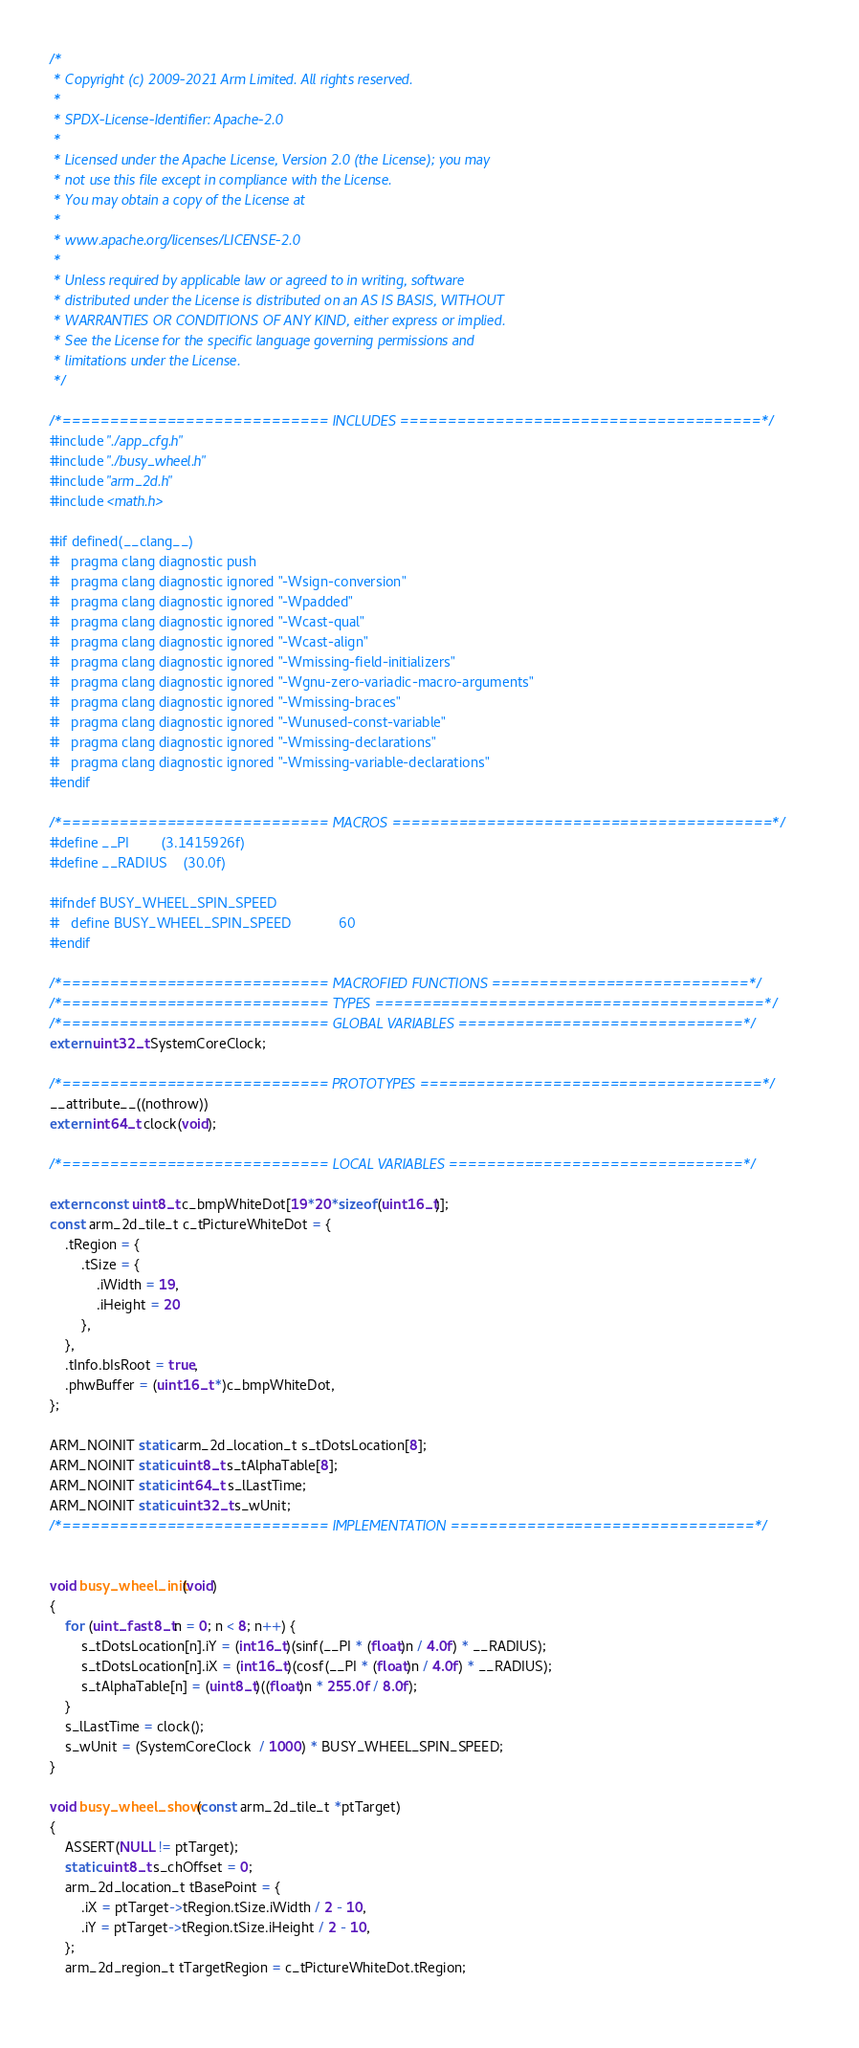<code> <loc_0><loc_0><loc_500><loc_500><_C_>/*
 * Copyright (c) 2009-2021 Arm Limited. All rights reserved.
 *
 * SPDX-License-Identifier: Apache-2.0
 *
 * Licensed under the Apache License, Version 2.0 (the License); you may
 * not use this file except in compliance with the License.
 * You may obtain a copy of the License at
 *
 * www.apache.org/licenses/LICENSE-2.0
 *
 * Unless required by applicable law or agreed to in writing, software
 * distributed under the License is distributed on an AS IS BASIS, WITHOUT
 * WARRANTIES OR CONDITIONS OF ANY KIND, either express or implied.
 * See the License for the specific language governing permissions and
 * limitations under the License.
 */

/*============================ INCLUDES ======================================*/
#include "./app_cfg.h"
#include "./busy_wheel.h"
#include "arm_2d.h"
#include <math.h>

#if defined(__clang__)
#   pragma clang diagnostic push
#   pragma clang diagnostic ignored "-Wsign-conversion"
#   pragma clang diagnostic ignored "-Wpadded"
#   pragma clang diagnostic ignored "-Wcast-qual"
#   pragma clang diagnostic ignored "-Wcast-align"
#   pragma clang diagnostic ignored "-Wmissing-field-initializers"
#   pragma clang diagnostic ignored "-Wgnu-zero-variadic-macro-arguments"
#   pragma clang diagnostic ignored "-Wmissing-braces"
#   pragma clang diagnostic ignored "-Wunused-const-variable"
#   pragma clang diagnostic ignored "-Wmissing-declarations"
#   pragma clang diagnostic ignored "-Wmissing-variable-declarations"
#endif

/*============================ MACROS ========================================*/
#define __PI        (3.1415926f)
#define __RADIUS    (30.0f)

#ifndef BUSY_WHEEL_SPIN_SPEED
#   define BUSY_WHEEL_SPIN_SPEED            60
#endif

/*============================ MACROFIED FUNCTIONS ===========================*/
/*============================ TYPES =========================================*/
/*============================ GLOBAL VARIABLES ==============================*/
extern uint32_t SystemCoreClock;

/*============================ PROTOTYPES ====================================*/
__attribute__((nothrow)) 
extern int64_t clock(void);

/*============================ LOCAL VARIABLES ===============================*/

extern const uint8_t c_bmpWhiteDot[19*20*sizeof(uint16_t)];
const arm_2d_tile_t c_tPictureWhiteDot = {
    .tRegion = {
        .tSize = {
            .iWidth = 19,
            .iHeight = 20
        },
    },
    .tInfo.bIsRoot = true,
    .phwBuffer = (uint16_t *)c_bmpWhiteDot,
};

ARM_NOINIT static arm_2d_location_t s_tDotsLocation[8];
ARM_NOINIT static uint8_t s_tAlphaTable[8];
ARM_NOINIT static int64_t s_lLastTime;
ARM_NOINIT static uint32_t s_wUnit;
/*============================ IMPLEMENTATION ================================*/


void busy_wheel_init(void)
{
    for (uint_fast8_t n = 0; n < 8; n++) {
        s_tDotsLocation[n].iY = (int16_t)(sinf(__PI * (float)n / 4.0f) * __RADIUS);
        s_tDotsLocation[n].iX = (int16_t)(cosf(__PI * (float)n / 4.0f) * __RADIUS);
        s_tAlphaTable[n] = (uint8_t)((float)n * 255.0f / 8.0f);
    }
    s_lLastTime = clock();
    s_wUnit = (SystemCoreClock  / 1000) * BUSY_WHEEL_SPIN_SPEED;
}

void busy_wheel_show(const arm_2d_tile_t *ptTarget)
{
    ASSERT(NULL != ptTarget);
    static uint8_t s_chOffset = 0;
    arm_2d_location_t tBasePoint = {
        .iX = ptTarget->tRegion.tSize.iWidth / 2 - 10,
        .iY = ptTarget->tRegion.tSize.iHeight / 2 - 10,
    };
    arm_2d_region_t tTargetRegion = c_tPictureWhiteDot.tRegion;
    </code> 